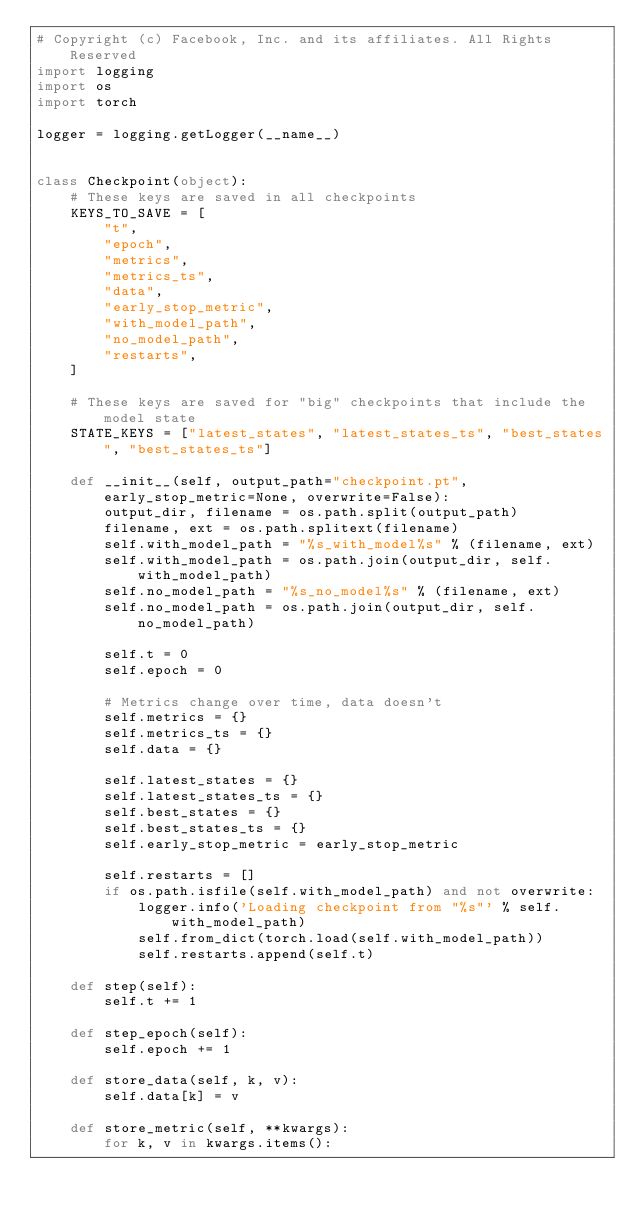Convert code to text. <code><loc_0><loc_0><loc_500><loc_500><_Python_># Copyright (c) Facebook, Inc. and its affiliates. All Rights Reserved
import logging
import os
import torch

logger = logging.getLogger(__name__)


class Checkpoint(object):
    # These keys are saved in all checkpoints
    KEYS_TO_SAVE = [
        "t",
        "epoch",
        "metrics",
        "metrics_ts",
        "data",
        "early_stop_metric",
        "with_model_path",
        "no_model_path",
        "restarts",
    ]

    # These keys are saved for "big" checkpoints that include the model state
    STATE_KEYS = ["latest_states", "latest_states_ts", "best_states", "best_states_ts"]

    def __init__(self, output_path="checkpoint.pt", early_stop_metric=None, overwrite=False):
        output_dir, filename = os.path.split(output_path)
        filename, ext = os.path.splitext(filename)
        self.with_model_path = "%s_with_model%s" % (filename, ext)
        self.with_model_path = os.path.join(output_dir, self.with_model_path)
        self.no_model_path = "%s_no_model%s" % (filename, ext)
        self.no_model_path = os.path.join(output_dir, self.no_model_path)

        self.t = 0
        self.epoch = 0

        # Metrics change over time, data doesn't
        self.metrics = {}
        self.metrics_ts = {}
        self.data = {}

        self.latest_states = {}
        self.latest_states_ts = {}
        self.best_states = {}
        self.best_states_ts = {}
        self.early_stop_metric = early_stop_metric

        self.restarts = []
        if os.path.isfile(self.with_model_path) and not overwrite:
            logger.info('Loading checkpoint from "%s"' % self.with_model_path)
            self.from_dict(torch.load(self.with_model_path))
            self.restarts.append(self.t)

    def step(self):
        self.t += 1

    def step_epoch(self):
        self.epoch += 1

    def store_data(self, k, v):
        self.data[k] = v

    def store_metric(self, **kwargs):
        for k, v in kwargs.items():</code> 